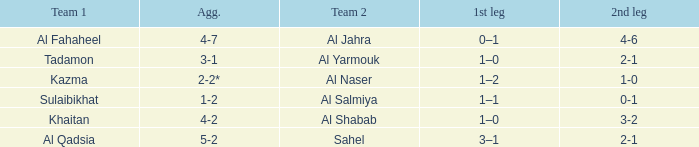What is the appellation of team 2 with al qadsia as team 1? Sahel. Can you parse all the data within this table? {'header': ['Team 1', 'Agg.', 'Team 2', '1st leg', '2nd leg'], 'rows': [['Al Fahaheel', '4-7', 'Al Jahra', '0–1', '4-6'], ['Tadamon', '3-1', 'Al Yarmouk', '1–0', '2-1'], ['Kazma', '2-2*', 'Al Naser', '1–2', '1-0'], ['Sulaibikhat', '1-2', 'Al Salmiya', '1–1', '0-1'], ['Khaitan', '4-2', 'Al Shabab', '1–0', '3-2'], ['Al Qadsia', '5-2', 'Sahel', '3–1', '2-1']]} 